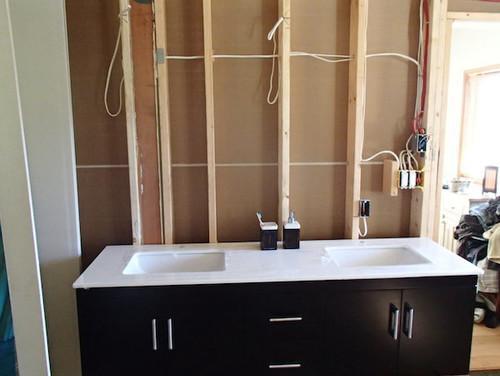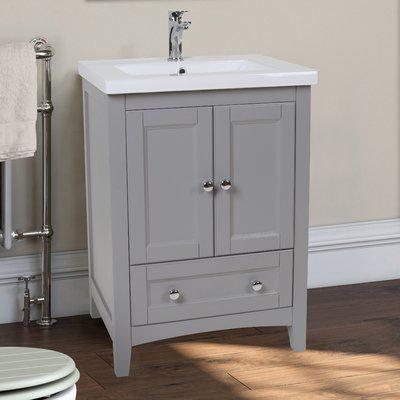The first image is the image on the left, the second image is the image on the right. Analyze the images presented: Is the assertion "In one image, a vanity the width of one sink has two doors and stands on short legs." valid? Answer yes or no. Yes. 